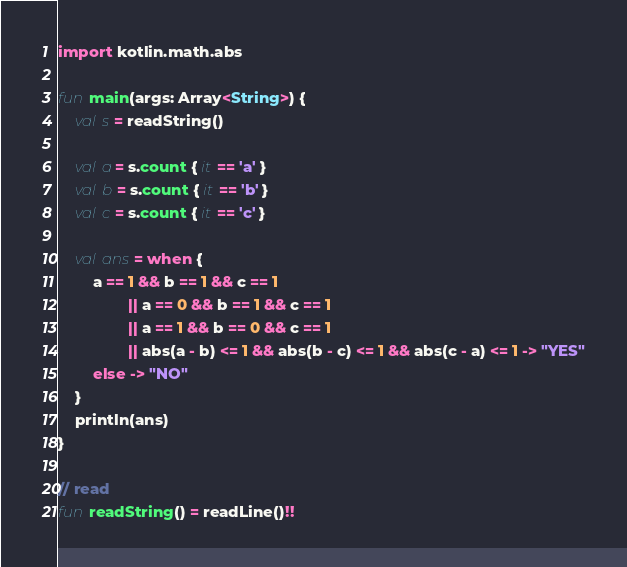Convert code to text. <code><loc_0><loc_0><loc_500><loc_500><_Kotlin_>import kotlin.math.abs

fun main(args: Array<String>) {
    val s = readString()

    val a = s.count { it == 'a' }
    val b = s.count { it == 'b' }
    val c = s.count { it == 'c' }

    val ans = when {
        a == 1 && b == 1 && c == 1
                || a == 0 && b == 1 && c == 1
                || a == 1 && b == 0 && c == 1
                || abs(a - b) <= 1 && abs(b - c) <= 1 && abs(c - a) <= 1 -> "YES"
        else -> "NO"
    }
    println(ans)
}

// read
fun readString() = readLine()!!</code> 